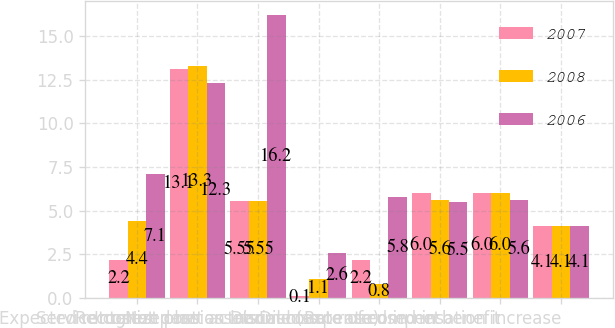Convert chart to OTSL. <chart><loc_0><loc_0><loc_500><loc_500><stacked_bar_chart><ecel><fcel>Service cost<fcel>Interest cost<fcel>Expected return on plan assets<fcel>Recognized net actuarial loss<fcel>Net pension income (expense)<fcel>Discount rate used in net<fcel>Discount rate used in benefit<fcel>Rate of compensation increase<nl><fcel>2007<fcel>2.2<fcel>13.1<fcel>5.55<fcel>0.1<fcel>2.2<fcel>6<fcel>6<fcel>4.1<nl><fcel>2008<fcel>4.4<fcel>13.3<fcel>5.55<fcel>1.1<fcel>0.8<fcel>5.6<fcel>6<fcel>4.1<nl><fcel>2006<fcel>7.1<fcel>12.3<fcel>16.2<fcel>2.6<fcel>5.8<fcel>5.5<fcel>5.6<fcel>4.1<nl></chart> 